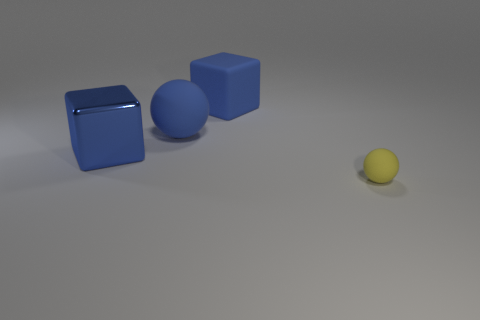Subtract all gray blocks. How many brown spheres are left? 0 Add 3 tiny objects. How many objects exist? 7 Add 1 large blue objects. How many large blue objects exist? 4 Subtract 0 red cubes. How many objects are left? 4 Subtract all green cubes. Subtract all gray balls. How many cubes are left? 2 Subtract all big brown cubes. Subtract all large matte objects. How many objects are left? 2 Add 4 big matte blocks. How many big matte blocks are left? 5 